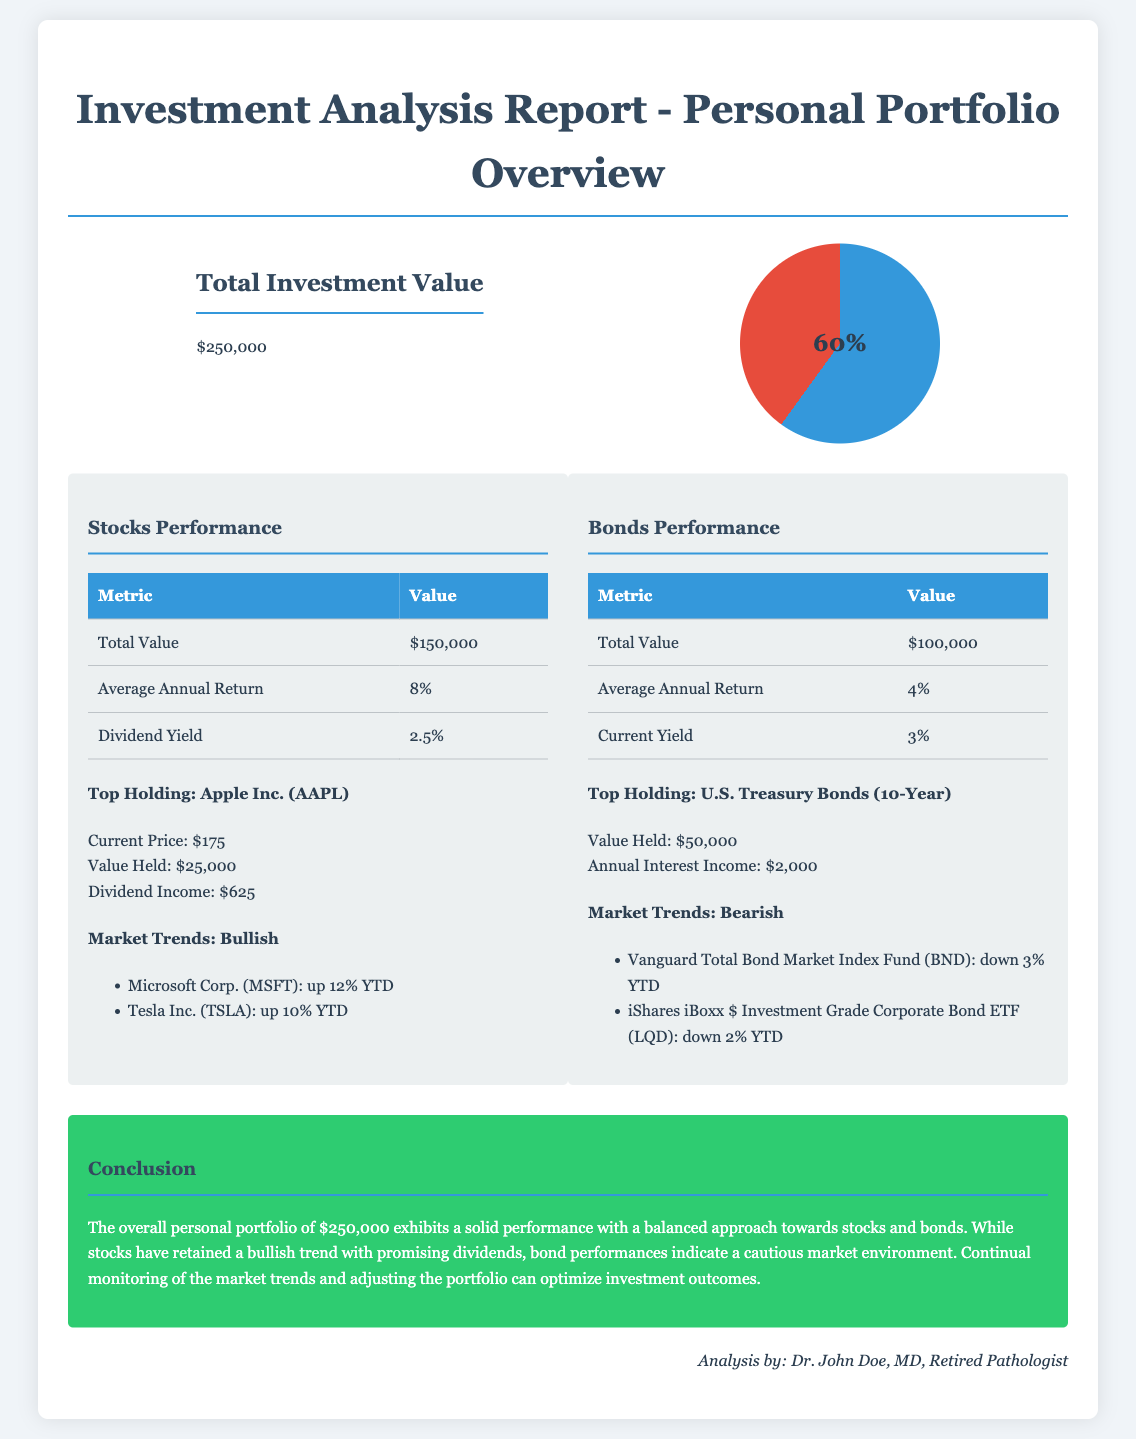What is the total investment value? The total investment value is the sum of all assets in the personal portfolio, which is stated in the document.
Answer: $250,000 What is the average annual return for stocks? This information is found under the stocks performance section, specifying the annual return percentage for stocks.
Answer: 8% What is the current yield for bonds? The current yield for bonds is provided in the bonds performance section, indicating the yield percentage.
Answer: 3% What is the top holding for stocks? This refers to the prominent stock mentioned in the report, indicating the most valuable stock in the portfolio.
Answer: Apple Inc. (AAPL) What is the annual interest income from the top bond holding? This amount represents the income generated from the top bond holding in the portfolio over the course of a year.
Answer: $2,000 Which stock is noted for being up 12% YTD? The document lists a specific stock with a noted year-to-date performance increase as part of market trends.
Answer: Microsoft Corp. (MSFT) What trend is indicated for bonds in the market analysis? This indicates the prevailing market sentiment for bonds based on the provided analysis in the document.
Answer: Bearish Which section provides the conclusion of the report? This section summarizes the overall findings and insights from the investment analysis and is distinctively labeled in the document.
Answer: Conclusion 